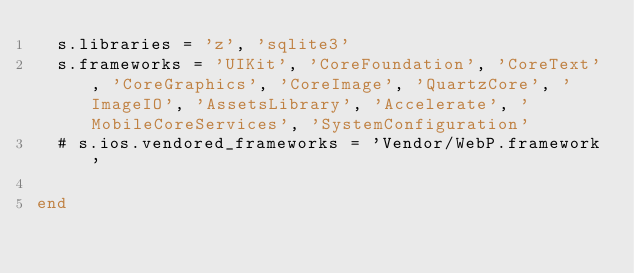Convert code to text. <code><loc_0><loc_0><loc_500><loc_500><_Ruby_>  s.libraries = 'z', 'sqlite3'
  s.frameworks = 'UIKit', 'CoreFoundation', 'CoreText', 'CoreGraphics', 'CoreImage', 'QuartzCore', 'ImageIO', 'AssetsLibrary', 'Accelerate', 'MobileCoreServices', 'SystemConfiguration'
  # s.ios.vendored_frameworks = 'Vendor/WebP.framework'

end
</code> 